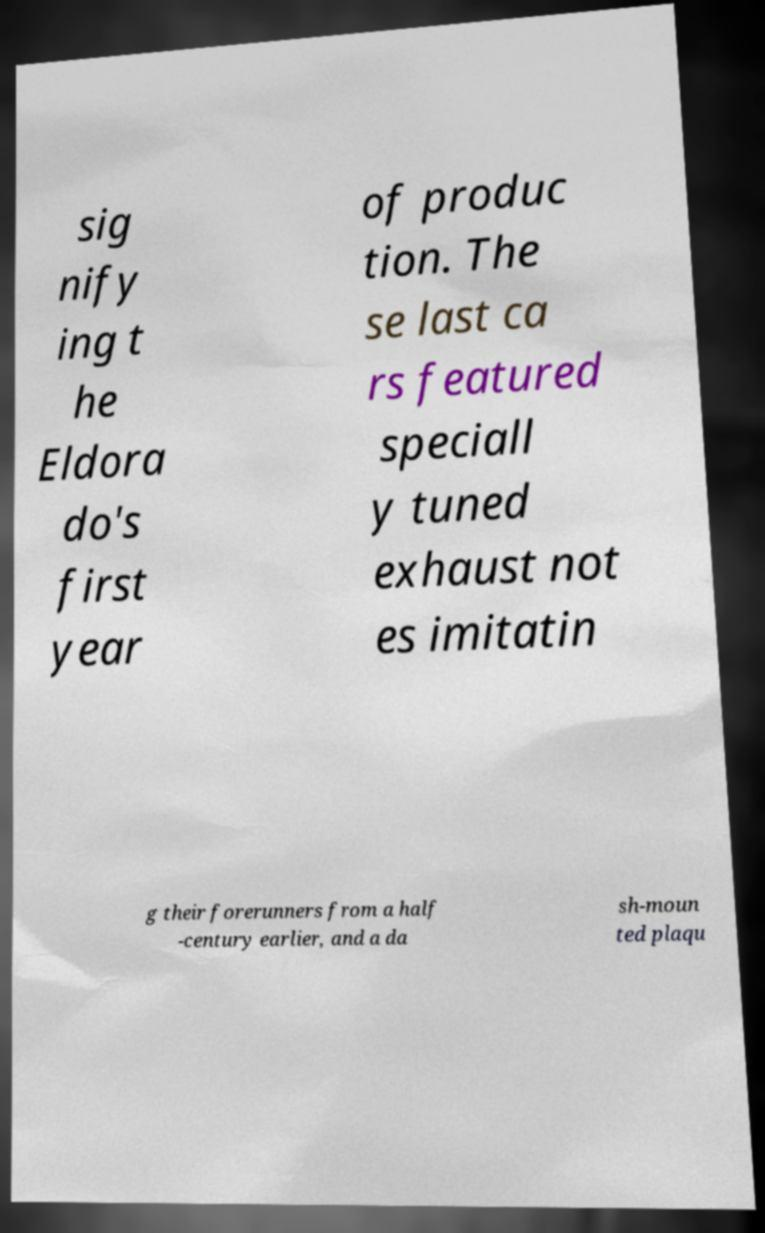There's text embedded in this image that I need extracted. Can you transcribe it verbatim? sig nify ing t he Eldora do's first year of produc tion. The se last ca rs featured speciall y tuned exhaust not es imitatin g their forerunners from a half -century earlier, and a da sh-moun ted plaqu 